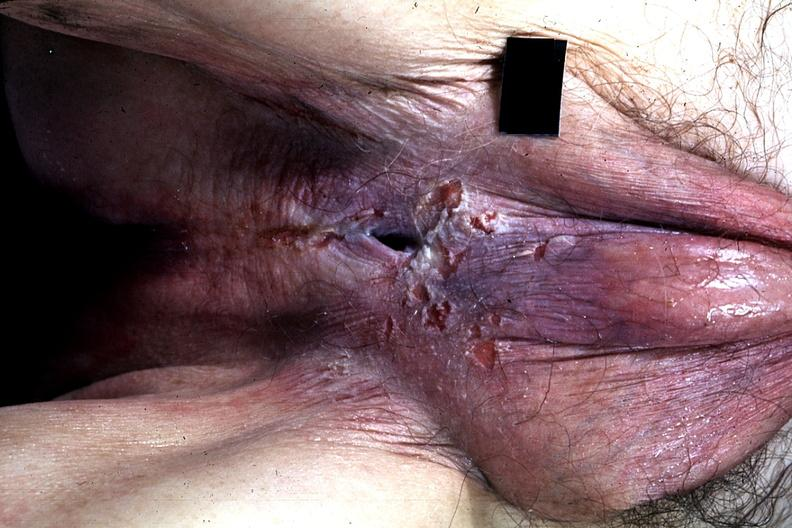what is present?
Answer the question using a single word or phrase. Hypospadias 